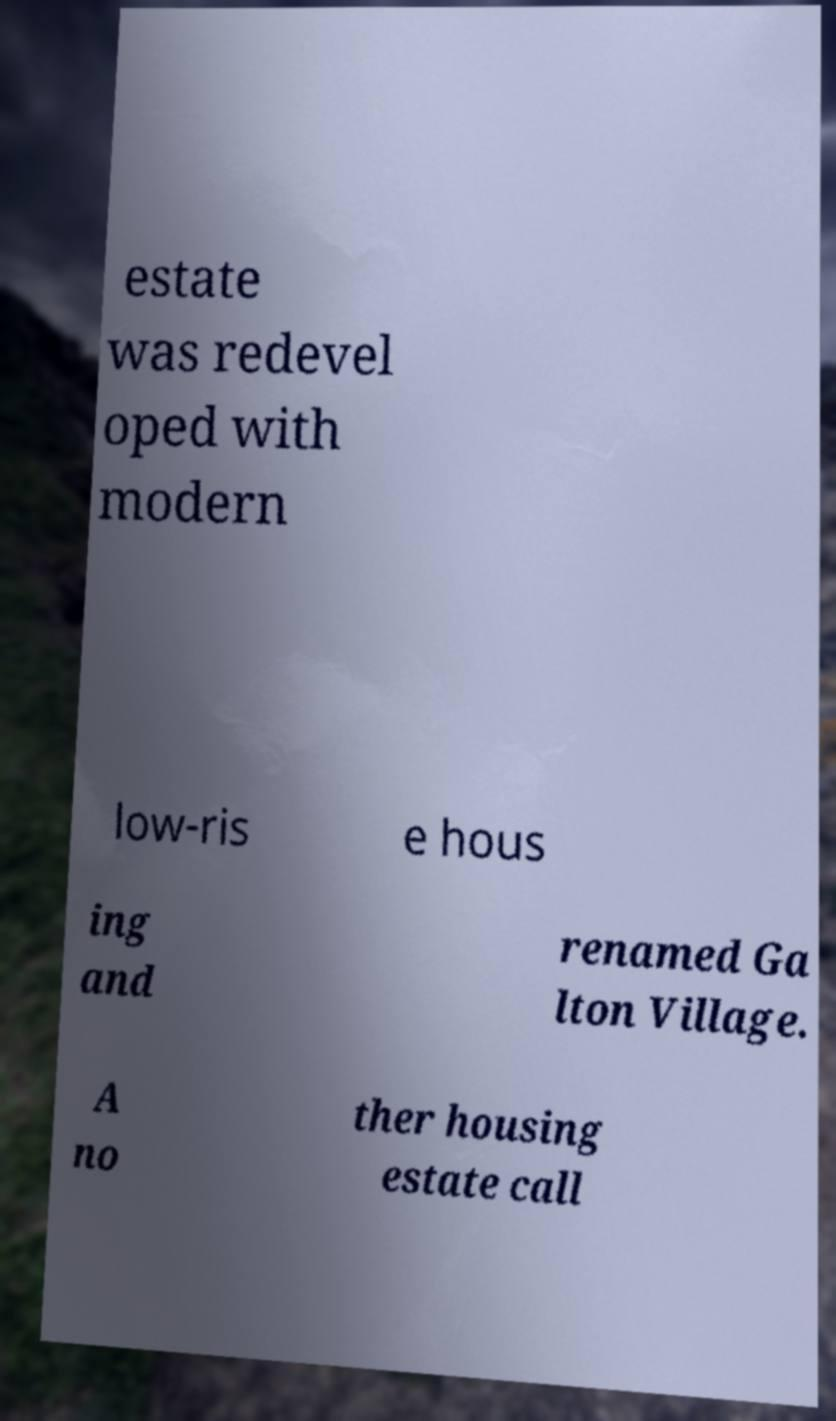Please read and relay the text visible in this image. What does it say? estate was redevel oped with modern low-ris e hous ing and renamed Ga lton Village. A no ther housing estate call 